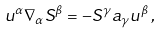<formula> <loc_0><loc_0><loc_500><loc_500>u ^ { \alpha } \nabla _ { \alpha } S ^ { \beta } = - S ^ { \gamma } a _ { \gamma } u ^ { \beta } \, ,</formula> 